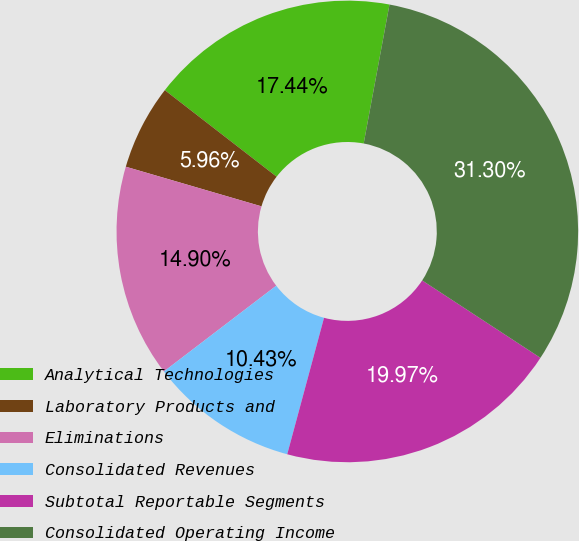Convert chart. <chart><loc_0><loc_0><loc_500><loc_500><pie_chart><fcel>Analytical Technologies<fcel>Laboratory Products and<fcel>Eliminations<fcel>Consolidated Revenues<fcel>Subtotal Reportable Segments<fcel>Consolidated Operating Income<nl><fcel>17.44%<fcel>5.96%<fcel>14.9%<fcel>10.43%<fcel>19.97%<fcel>31.3%<nl></chart> 